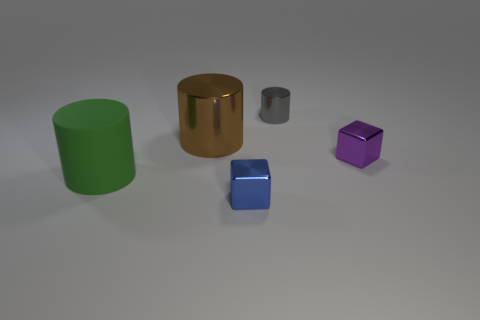Can you describe the texture and color of the purple cube? Certainly! The purple cube in the image has a polished, smooth texture with a reflective surface, suggesting it's made of a material like metal or plastic. Its color is a vibrant shade of purple that catches the light, giving it a lustrous appearance. 